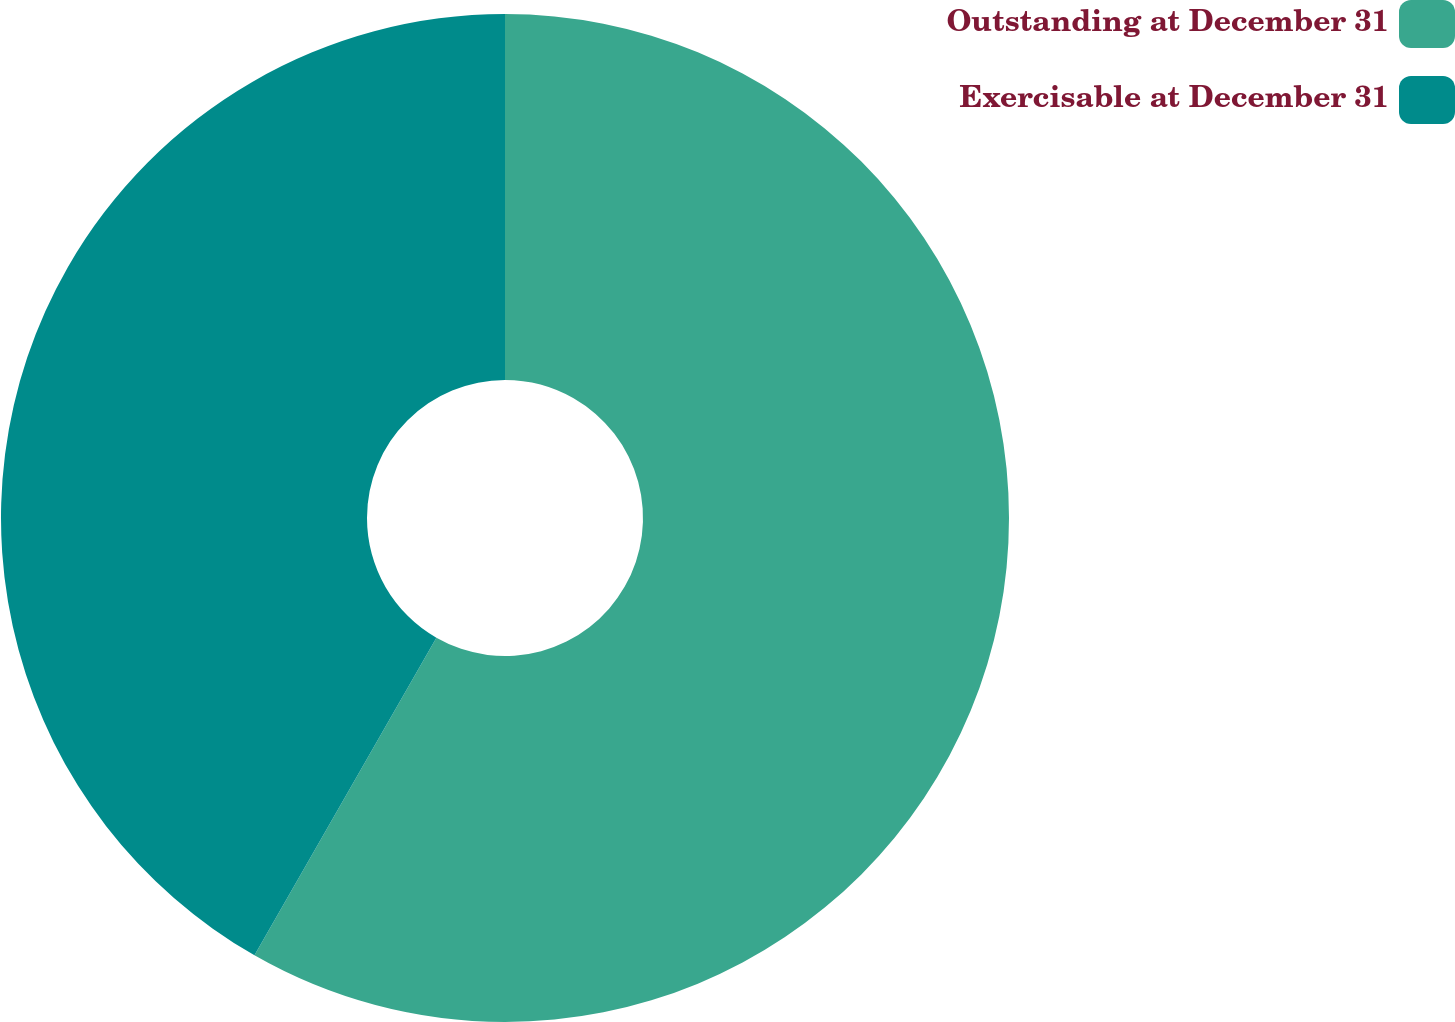<chart> <loc_0><loc_0><loc_500><loc_500><pie_chart><fcel>Outstanding at December 31<fcel>Exercisable at December 31<nl><fcel>58.28%<fcel>41.72%<nl></chart> 